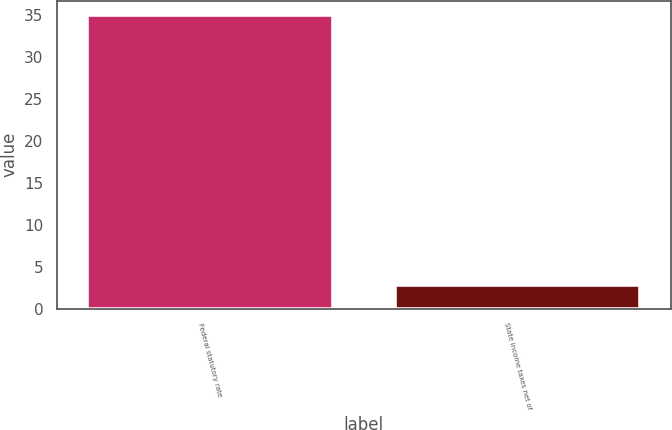Convert chart. <chart><loc_0><loc_0><loc_500><loc_500><bar_chart><fcel>Federal statutory rate<fcel>State income taxes net of<nl><fcel>35<fcel>2.9<nl></chart> 